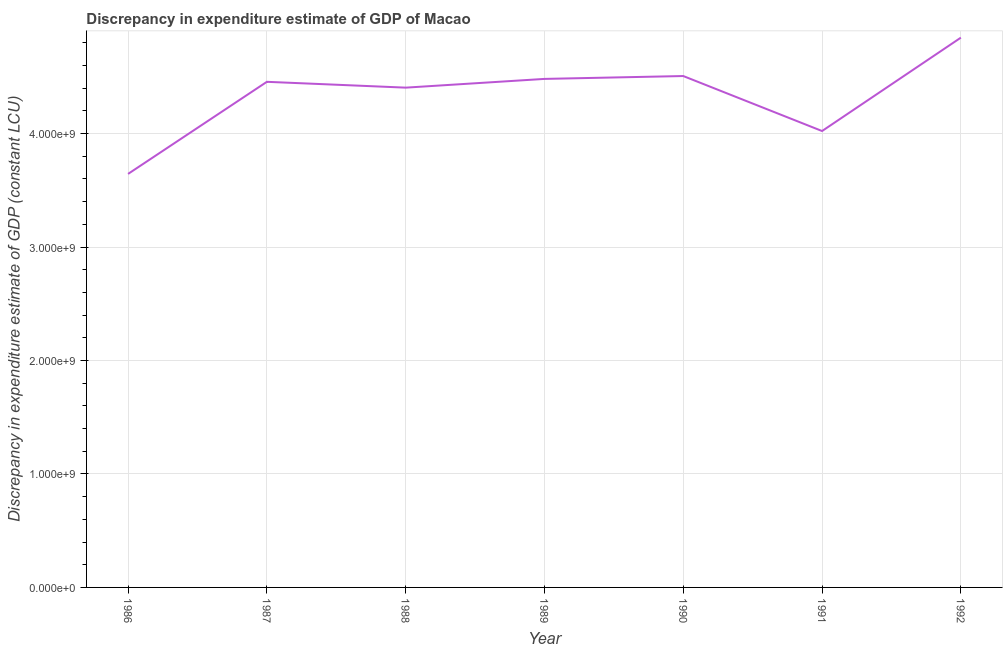What is the discrepancy in expenditure estimate of gdp in 1986?
Your response must be concise. 3.64e+09. Across all years, what is the maximum discrepancy in expenditure estimate of gdp?
Ensure brevity in your answer.  4.85e+09. Across all years, what is the minimum discrepancy in expenditure estimate of gdp?
Provide a succinct answer. 3.64e+09. In which year was the discrepancy in expenditure estimate of gdp minimum?
Make the answer very short. 1986. What is the sum of the discrepancy in expenditure estimate of gdp?
Your response must be concise. 3.04e+1. What is the difference between the discrepancy in expenditure estimate of gdp in 1987 and 1989?
Ensure brevity in your answer.  -2.56e+07. What is the average discrepancy in expenditure estimate of gdp per year?
Make the answer very short. 4.34e+09. What is the median discrepancy in expenditure estimate of gdp?
Your answer should be compact. 4.46e+09. In how many years, is the discrepancy in expenditure estimate of gdp greater than 1400000000 LCU?
Give a very brief answer. 7. Do a majority of the years between 1986 and 1988 (inclusive) have discrepancy in expenditure estimate of gdp greater than 3000000000 LCU?
Your answer should be very brief. Yes. What is the ratio of the discrepancy in expenditure estimate of gdp in 1988 to that in 1991?
Offer a terse response. 1.1. Is the discrepancy in expenditure estimate of gdp in 1990 less than that in 1991?
Your answer should be very brief. No. Is the difference between the discrepancy in expenditure estimate of gdp in 1986 and 1990 greater than the difference between any two years?
Your response must be concise. No. What is the difference between the highest and the second highest discrepancy in expenditure estimate of gdp?
Your response must be concise. 3.38e+08. What is the difference between the highest and the lowest discrepancy in expenditure estimate of gdp?
Your response must be concise. 1.20e+09. In how many years, is the discrepancy in expenditure estimate of gdp greater than the average discrepancy in expenditure estimate of gdp taken over all years?
Your answer should be compact. 5. How many years are there in the graph?
Your answer should be very brief. 7. Does the graph contain any zero values?
Your answer should be very brief. No. What is the title of the graph?
Offer a terse response. Discrepancy in expenditure estimate of GDP of Macao. What is the label or title of the X-axis?
Keep it short and to the point. Year. What is the label or title of the Y-axis?
Your answer should be very brief. Discrepancy in expenditure estimate of GDP (constant LCU). What is the Discrepancy in expenditure estimate of GDP (constant LCU) in 1986?
Ensure brevity in your answer.  3.64e+09. What is the Discrepancy in expenditure estimate of GDP (constant LCU) in 1987?
Provide a short and direct response. 4.46e+09. What is the Discrepancy in expenditure estimate of GDP (constant LCU) of 1988?
Provide a short and direct response. 4.41e+09. What is the Discrepancy in expenditure estimate of GDP (constant LCU) of 1989?
Keep it short and to the point. 4.48e+09. What is the Discrepancy in expenditure estimate of GDP (constant LCU) in 1990?
Provide a short and direct response. 4.51e+09. What is the Discrepancy in expenditure estimate of GDP (constant LCU) in 1991?
Give a very brief answer. 4.02e+09. What is the Discrepancy in expenditure estimate of GDP (constant LCU) in 1992?
Give a very brief answer. 4.85e+09. What is the difference between the Discrepancy in expenditure estimate of GDP (constant LCU) in 1986 and 1987?
Your answer should be very brief. -8.12e+08. What is the difference between the Discrepancy in expenditure estimate of GDP (constant LCU) in 1986 and 1988?
Provide a short and direct response. -7.60e+08. What is the difference between the Discrepancy in expenditure estimate of GDP (constant LCU) in 1986 and 1989?
Your answer should be very brief. -8.37e+08. What is the difference between the Discrepancy in expenditure estimate of GDP (constant LCU) in 1986 and 1990?
Make the answer very short. -8.63e+08. What is the difference between the Discrepancy in expenditure estimate of GDP (constant LCU) in 1986 and 1991?
Give a very brief answer. -3.78e+08. What is the difference between the Discrepancy in expenditure estimate of GDP (constant LCU) in 1986 and 1992?
Make the answer very short. -1.20e+09. What is the difference between the Discrepancy in expenditure estimate of GDP (constant LCU) in 1987 and 1988?
Make the answer very short. 5.14e+07. What is the difference between the Discrepancy in expenditure estimate of GDP (constant LCU) in 1987 and 1989?
Your answer should be very brief. -2.56e+07. What is the difference between the Discrepancy in expenditure estimate of GDP (constant LCU) in 1987 and 1990?
Your response must be concise. -5.10e+07. What is the difference between the Discrepancy in expenditure estimate of GDP (constant LCU) in 1987 and 1991?
Ensure brevity in your answer.  4.34e+08. What is the difference between the Discrepancy in expenditure estimate of GDP (constant LCU) in 1987 and 1992?
Make the answer very short. -3.89e+08. What is the difference between the Discrepancy in expenditure estimate of GDP (constant LCU) in 1988 and 1989?
Ensure brevity in your answer.  -7.70e+07. What is the difference between the Discrepancy in expenditure estimate of GDP (constant LCU) in 1988 and 1990?
Your answer should be very brief. -1.02e+08. What is the difference between the Discrepancy in expenditure estimate of GDP (constant LCU) in 1988 and 1991?
Your response must be concise. 3.82e+08. What is the difference between the Discrepancy in expenditure estimate of GDP (constant LCU) in 1988 and 1992?
Your answer should be very brief. -4.41e+08. What is the difference between the Discrepancy in expenditure estimate of GDP (constant LCU) in 1989 and 1990?
Make the answer very short. -2.53e+07. What is the difference between the Discrepancy in expenditure estimate of GDP (constant LCU) in 1989 and 1991?
Your answer should be very brief. 4.59e+08. What is the difference between the Discrepancy in expenditure estimate of GDP (constant LCU) in 1989 and 1992?
Provide a succinct answer. -3.64e+08. What is the difference between the Discrepancy in expenditure estimate of GDP (constant LCU) in 1990 and 1991?
Provide a succinct answer. 4.85e+08. What is the difference between the Discrepancy in expenditure estimate of GDP (constant LCU) in 1990 and 1992?
Give a very brief answer. -3.38e+08. What is the difference between the Discrepancy in expenditure estimate of GDP (constant LCU) in 1991 and 1992?
Make the answer very short. -8.23e+08. What is the ratio of the Discrepancy in expenditure estimate of GDP (constant LCU) in 1986 to that in 1987?
Your answer should be very brief. 0.82. What is the ratio of the Discrepancy in expenditure estimate of GDP (constant LCU) in 1986 to that in 1988?
Make the answer very short. 0.83. What is the ratio of the Discrepancy in expenditure estimate of GDP (constant LCU) in 1986 to that in 1989?
Your response must be concise. 0.81. What is the ratio of the Discrepancy in expenditure estimate of GDP (constant LCU) in 1986 to that in 1990?
Your answer should be very brief. 0.81. What is the ratio of the Discrepancy in expenditure estimate of GDP (constant LCU) in 1986 to that in 1991?
Your response must be concise. 0.91. What is the ratio of the Discrepancy in expenditure estimate of GDP (constant LCU) in 1986 to that in 1992?
Offer a terse response. 0.75. What is the ratio of the Discrepancy in expenditure estimate of GDP (constant LCU) in 1987 to that in 1990?
Your answer should be compact. 0.99. What is the ratio of the Discrepancy in expenditure estimate of GDP (constant LCU) in 1987 to that in 1991?
Give a very brief answer. 1.11. What is the ratio of the Discrepancy in expenditure estimate of GDP (constant LCU) in 1987 to that in 1992?
Offer a very short reply. 0.92. What is the ratio of the Discrepancy in expenditure estimate of GDP (constant LCU) in 1988 to that in 1989?
Ensure brevity in your answer.  0.98. What is the ratio of the Discrepancy in expenditure estimate of GDP (constant LCU) in 1988 to that in 1991?
Provide a succinct answer. 1.09. What is the ratio of the Discrepancy in expenditure estimate of GDP (constant LCU) in 1988 to that in 1992?
Offer a very short reply. 0.91. What is the ratio of the Discrepancy in expenditure estimate of GDP (constant LCU) in 1989 to that in 1991?
Give a very brief answer. 1.11. What is the ratio of the Discrepancy in expenditure estimate of GDP (constant LCU) in 1989 to that in 1992?
Keep it short and to the point. 0.93. What is the ratio of the Discrepancy in expenditure estimate of GDP (constant LCU) in 1990 to that in 1991?
Make the answer very short. 1.12. What is the ratio of the Discrepancy in expenditure estimate of GDP (constant LCU) in 1991 to that in 1992?
Make the answer very short. 0.83. 